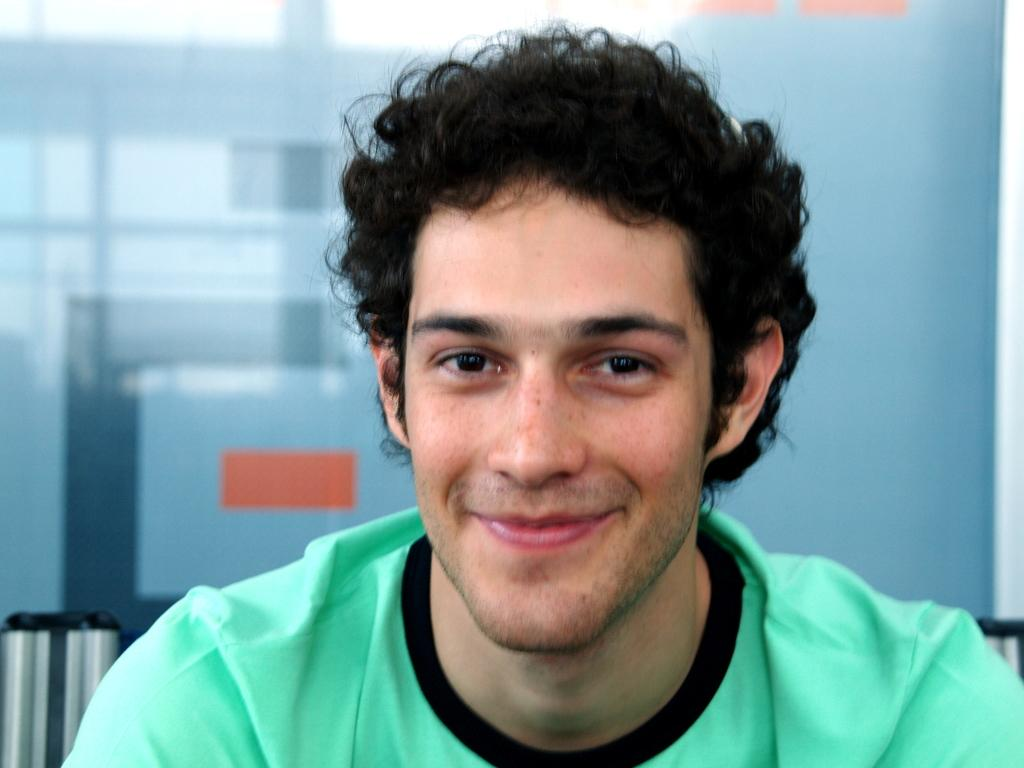Who or what is the main subject in the image? There is a person in the image. What is the person wearing? The person is wearing a green color t-shirt. Where is the person located in the image? The person is located in the center of the image. How many pigs are flying a plane in the image? There are no pigs or planes present in the image. Are the person's friends visible in the image? The provided facts do not mention any friends, so we cannot determine if they are visible in the image. 